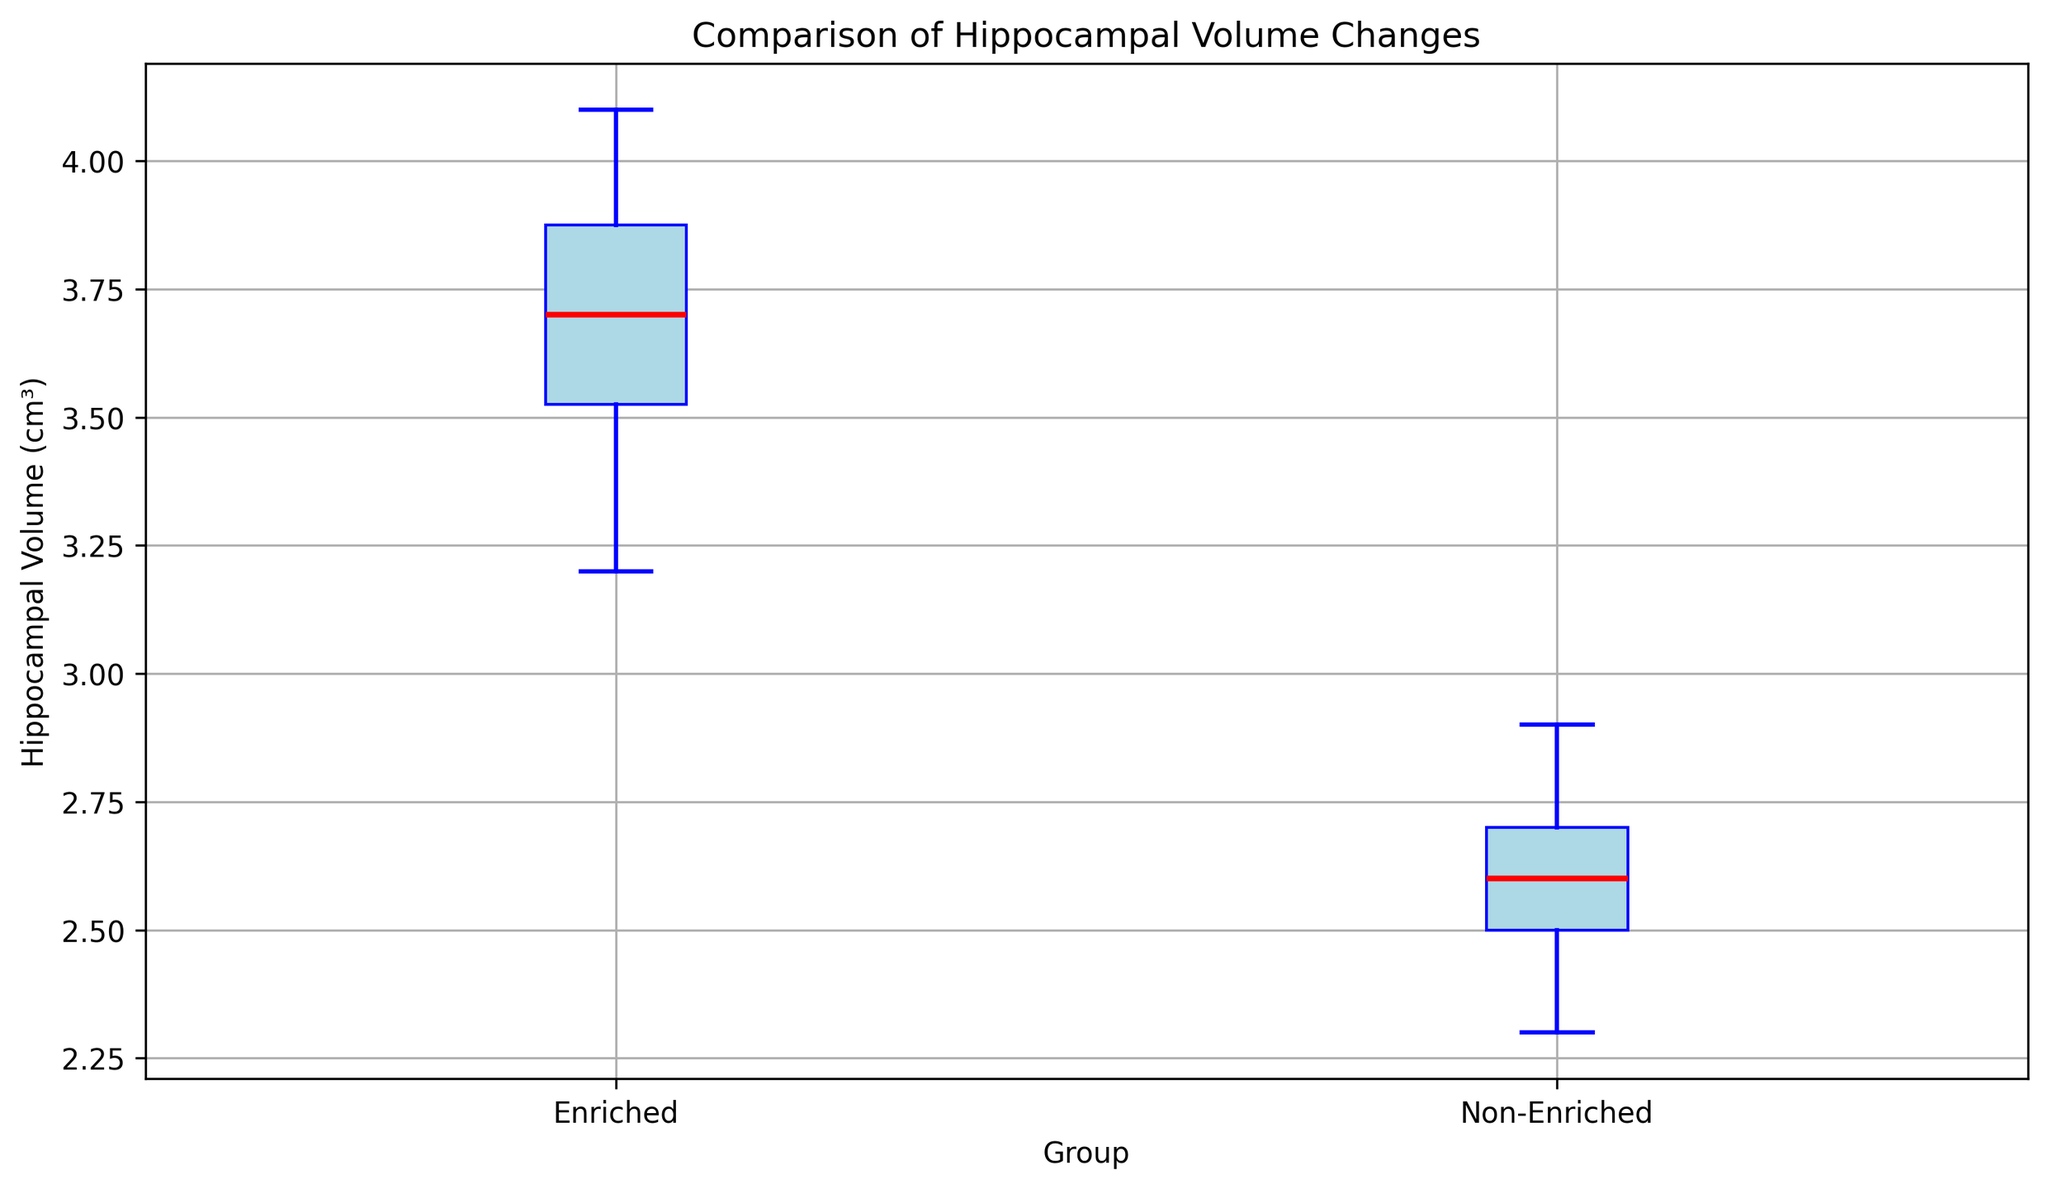What's the median value of the Enriched group? Find the median value by ordering all data points in the Enriched group and selecting the middle one. Here, the ordered values are 3.2, 3.5, 3.5, 3.6, 3.7, 3.7, 3.8, 3.9, 4.0, 4.1. The median is the average of the 5th and 6th values, which are both 3.7.
Answer: 3.7 Which group has a higher maximum hippocampal volume? Compare the maximum hippocampal volume values in each group. The maximum value for the Enriched group is 4.1, and for the Non-Enriched group, it is 2.9.
Answer: Enriched What is the interquartile range (IQR) of the Non-Enriched group? The IQR is calculated as the difference between the 75th percentile and the 25th percentile values. For the Non-Enriched group, order the values: 2.3, 2.4, 2.5, 2.5, 2.6, 2.6, 2.7, 2.7, 2.8, 2.9. The 25th percentile (Q1) is 2.5 and the 75th percentile (Q3) is 2.7. IQR is 2.7 - 2.5.
Answer: 0.2 How does the range of hippocampal volumes compare between the two groups? The range is calculated as the difference between the maximum and minimum values. The Enriched group has a range of 4.1 - 3.2 = 0.9, while the Non-Enriched group has a range of 2.9 - 2.3 = 0.6.
Answer: The Enriched group has a larger range Which group has the smaller median hippocampal volume? Compare the median values of the two groups. The median for the Enriched group is 3.7, and for the Non-Enriched group, it is around 2.6.
Answer: Non-Enriched What is the color of the median line in the box plot? Observe the color of the line marking the median in the box plot. It is mentioned that the median line is colored red.
Answer: Red Where are the outliers more prominent, in the Enriched or Non-Enriched group? Examine the plot for any additional points outside the whiskers. Here, the outliers are shown with distinct markers. There are no distinct outliers visible for either group in the plot.
Answer: Neither What is the approximate difference between the means of the Enriched and Non-Enriched groups? Calculate the approximate mean by summing up the values and dividing by the number of values. For the Enriched group, the mean is approximately (3.2+3.5+3.7+4.0+3.9+3.6+3.8+4.1+3.5+3.7)/10 = 3.7, and for the Non-Enriched group, it's (2.6+2.8+2.7+2.9+2.5+2.4+2.7+2.3+2.6+2.5)/10 = 2.6. The difference is 3.7 - 2.6.
Answer: 1.1 